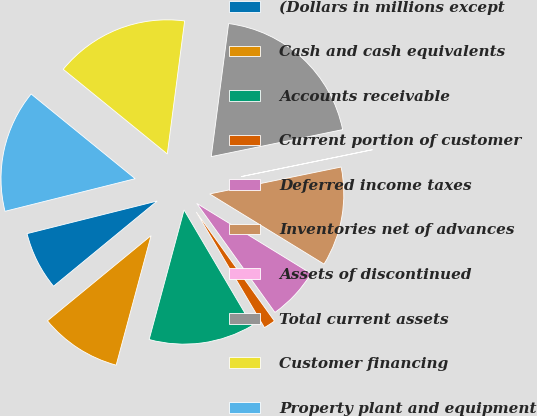Convert chart. <chart><loc_0><loc_0><loc_500><loc_500><pie_chart><fcel>(Dollars in millions except<fcel>Cash and cash equivalents<fcel>Accounts receivable<fcel>Current portion of customer<fcel>Deferred income taxes<fcel>Inventories net of advances<fcel>Assets of discontinued<fcel>Total current assets<fcel>Customer financing<fcel>Property plant and equipment<nl><fcel>7.04%<fcel>9.86%<fcel>12.67%<fcel>1.42%<fcel>6.34%<fcel>11.97%<fcel>0.01%<fcel>19.71%<fcel>16.19%<fcel>14.78%<nl></chart> 